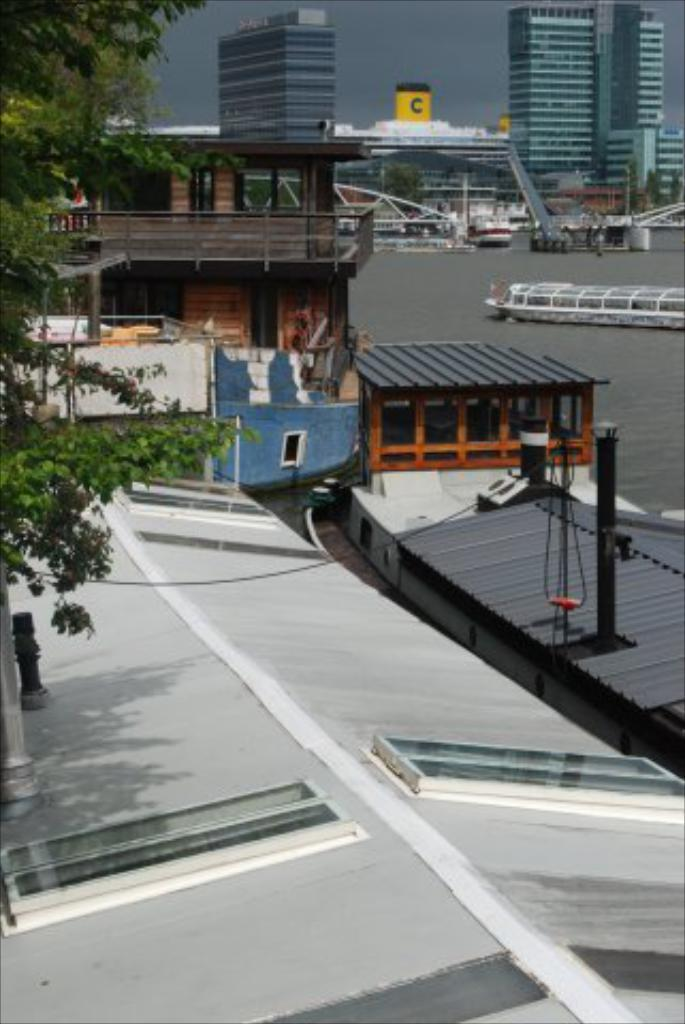What can be seen in the background of the image? There is sky and buildings visible in the background of the image. What is located on the left side of the image? There is a tree on the left side of the image. What is the primary feature of the image? There is water visible in the image. What is present in the water? There are ships present in the water. What type of art can be seen on the tree in the image? There is no art present on the tree in the image; it is a natural tree with no human-made additions. 